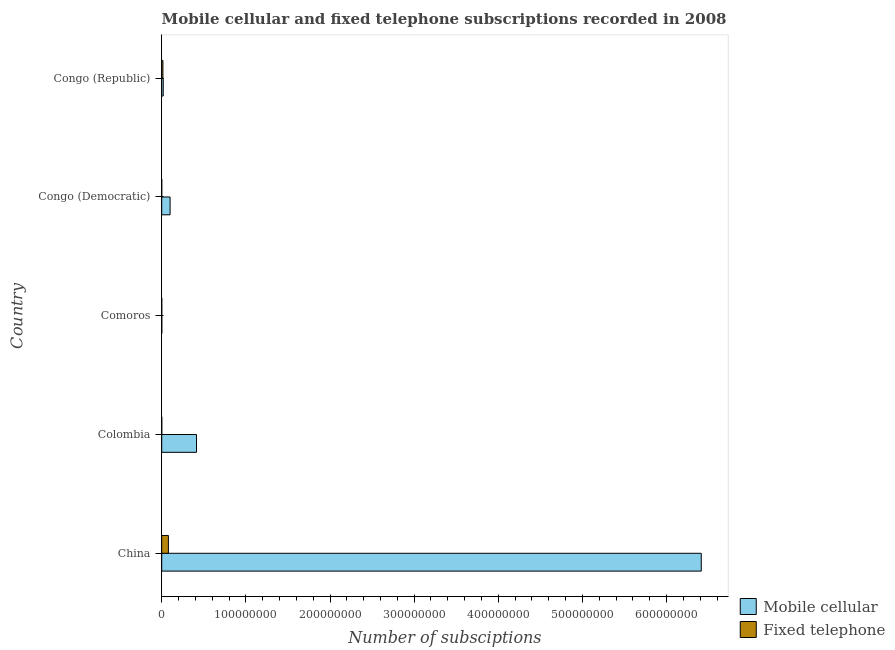How many different coloured bars are there?
Your response must be concise. 2. Are the number of bars per tick equal to the number of legend labels?
Ensure brevity in your answer.  Yes. How many bars are there on the 3rd tick from the top?
Offer a terse response. 2. What is the number of fixed telephone subscriptions in Congo (Republic)?
Keep it short and to the point. 1.44e+06. Across all countries, what is the maximum number of fixed telephone subscriptions?
Ensure brevity in your answer.  7.93e+06. Across all countries, what is the minimum number of fixed telephone subscriptions?
Ensure brevity in your answer.  9050. In which country was the number of fixed telephone subscriptions minimum?
Provide a short and direct response. Congo (Democratic). What is the total number of fixed telephone subscriptions in the graph?
Make the answer very short. 9.44e+06. What is the difference between the number of fixed telephone subscriptions in China and that in Congo (Democratic)?
Ensure brevity in your answer.  7.92e+06. What is the difference between the number of mobile cellular subscriptions in China and the number of fixed telephone subscriptions in Comoros?
Offer a terse response. 6.41e+08. What is the average number of mobile cellular subscriptions per country?
Your answer should be very brief. 1.39e+08. What is the difference between the number of fixed telephone subscriptions and number of mobile cellular subscriptions in Congo (Democratic)?
Offer a very short reply. -9.93e+06. In how many countries, is the number of fixed telephone subscriptions greater than 200000000 ?
Your answer should be compact. 0. What is the ratio of the number of mobile cellular subscriptions in China to that in Congo (Democratic)?
Provide a short and direct response. 64.53. What is the difference between the highest and the second highest number of fixed telephone subscriptions?
Your answer should be very brief. 6.49e+06. What is the difference between the highest and the lowest number of mobile cellular subscriptions?
Offer a very short reply. 6.41e+08. In how many countries, is the number of mobile cellular subscriptions greater than the average number of mobile cellular subscriptions taken over all countries?
Your answer should be compact. 1. Is the sum of the number of mobile cellular subscriptions in Colombia and Congo (Republic) greater than the maximum number of fixed telephone subscriptions across all countries?
Offer a very short reply. Yes. What does the 2nd bar from the top in Congo (Democratic) represents?
Your response must be concise. Mobile cellular. What does the 1st bar from the bottom in Comoros represents?
Make the answer very short. Mobile cellular. How many bars are there?
Your response must be concise. 10. Are all the bars in the graph horizontal?
Keep it short and to the point. Yes. What is the difference between two consecutive major ticks on the X-axis?
Provide a short and direct response. 1.00e+08. Are the values on the major ticks of X-axis written in scientific E-notation?
Keep it short and to the point. No. Where does the legend appear in the graph?
Your answer should be compact. Bottom right. How many legend labels are there?
Provide a short and direct response. 2. What is the title of the graph?
Your answer should be very brief. Mobile cellular and fixed telephone subscriptions recorded in 2008. What is the label or title of the X-axis?
Give a very brief answer. Number of subsciptions. What is the Number of subsciptions in Mobile cellular in China?
Ensure brevity in your answer.  6.41e+08. What is the Number of subsciptions of Fixed telephone in China?
Give a very brief answer. 7.93e+06. What is the Number of subsciptions of Mobile cellular in Colombia?
Your answer should be very brief. 4.14e+07. What is the Number of subsciptions in Fixed telephone in Colombia?
Provide a short and direct response. 2.88e+04. What is the Number of subsciptions of Mobile cellular in Comoros?
Ensure brevity in your answer.  9.17e+04. What is the Number of subsciptions in Fixed telephone in Comoros?
Ensure brevity in your answer.  3.73e+04. What is the Number of subsciptions in Mobile cellular in Congo (Democratic)?
Provide a short and direct response. 9.94e+06. What is the Number of subsciptions in Fixed telephone in Congo (Democratic)?
Provide a short and direct response. 9050. What is the Number of subsciptions of Mobile cellular in Congo (Republic)?
Keep it short and to the point. 1.81e+06. What is the Number of subsciptions of Fixed telephone in Congo (Republic)?
Provide a succinct answer. 1.44e+06. Across all countries, what is the maximum Number of subsciptions of Mobile cellular?
Offer a terse response. 6.41e+08. Across all countries, what is the maximum Number of subsciptions of Fixed telephone?
Provide a short and direct response. 7.93e+06. Across all countries, what is the minimum Number of subsciptions of Mobile cellular?
Provide a succinct answer. 9.17e+04. Across all countries, what is the minimum Number of subsciptions of Fixed telephone?
Your response must be concise. 9050. What is the total Number of subsciptions in Mobile cellular in the graph?
Offer a very short reply. 6.94e+08. What is the total Number of subsciptions of Fixed telephone in the graph?
Provide a short and direct response. 9.44e+06. What is the difference between the Number of subsciptions in Mobile cellular in China and that in Colombia?
Provide a short and direct response. 6.00e+08. What is the difference between the Number of subsciptions in Fixed telephone in China and that in Colombia?
Give a very brief answer. 7.90e+06. What is the difference between the Number of subsciptions of Mobile cellular in China and that in Comoros?
Make the answer very short. 6.41e+08. What is the difference between the Number of subsciptions of Fixed telephone in China and that in Comoros?
Offer a terse response. 7.89e+06. What is the difference between the Number of subsciptions in Mobile cellular in China and that in Congo (Democratic)?
Make the answer very short. 6.31e+08. What is the difference between the Number of subsciptions of Fixed telephone in China and that in Congo (Democratic)?
Offer a very short reply. 7.92e+06. What is the difference between the Number of subsciptions in Mobile cellular in China and that in Congo (Republic)?
Give a very brief answer. 6.39e+08. What is the difference between the Number of subsciptions of Fixed telephone in China and that in Congo (Republic)?
Offer a terse response. 6.49e+06. What is the difference between the Number of subsciptions in Mobile cellular in Colombia and that in Comoros?
Provide a short and direct response. 4.13e+07. What is the difference between the Number of subsciptions in Fixed telephone in Colombia and that in Comoros?
Your answer should be very brief. -8511. What is the difference between the Number of subsciptions in Mobile cellular in Colombia and that in Congo (Democratic)?
Give a very brief answer. 3.14e+07. What is the difference between the Number of subsciptions of Fixed telephone in Colombia and that in Congo (Democratic)?
Provide a succinct answer. 1.98e+04. What is the difference between the Number of subsciptions of Mobile cellular in Colombia and that in Congo (Republic)?
Offer a very short reply. 3.96e+07. What is the difference between the Number of subsciptions of Fixed telephone in Colombia and that in Congo (Republic)?
Make the answer very short. -1.41e+06. What is the difference between the Number of subsciptions of Mobile cellular in Comoros and that in Congo (Democratic)?
Provide a succinct answer. -9.85e+06. What is the difference between the Number of subsciptions of Fixed telephone in Comoros and that in Congo (Democratic)?
Give a very brief answer. 2.83e+04. What is the difference between the Number of subsciptions of Mobile cellular in Comoros and that in Congo (Republic)?
Keep it short and to the point. -1.72e+06. What is the difference between the Number of subsciptions in Fixed telephone in Comoros and that in Congo (Republic)?
Make the answer very short. -1.40e+06. What is the difference between the Number of subsciptions of Mobile cellular in Congo (Democratic) and that in Congo (Republic)?
Provide a short and direct response. 8.13e+06. What is the difference between the Number of subsciptions of Fixed telephone in Congo (Democratic) and that in Congo (Republic)?
Your answer should be compact. -1.43e+06. What is the difference between the Number of subsciptions in Mobile cellular in China and the Number of subsciptions in Fixed telephone in Colombia?
Offer a terse response. 6.41e+08. What is the difference between the Number of subsciptions of Mobile cellular in China and the Number of subsciptions of Fixed telephone in Comoros?
Provide a succinct answer. 6.41e+08. What is the difference between the Number of subsciptions of Mobile cellular in China and the Number of subsciptions of Fixed telephone in Congo (Democratic)?
Your response must be concise. 6.41e+08. What is the difference between the Number of subsciptions in Mobile cellular in China and the Number of subsciptions in Fixed telephone in Congo (Republic)?
Provide a succinct answer. 6.40e+08. What is the difference between the Number of subsciptions of Mobile cellular in Colombia and the Number of subsciptions of Fixed telephone in Comoros?
Give a very brief answer. 4.13e+07. What is the difference between the Number of subsciptions in Mobile cellular in Colombia and the Number of subsciptions in Fixed telephone in Congo (Democratic)?
Make the answer very short. 4.14e+07. What is the difference between the Number of subsciptions of Mobile cellular in Colombia and the Number of subsciptions of Fixed telephone in Congo (Republic)?
Keep it short and to the point. 3.99e+07. What is the difference between the Number of subsciptions of Mobile cellular in Comoros and the Number of subsciptions of Fixed telephone in Congo (Democratic)?
Give a very brief answer. 8.27e+04. What is the difference between the Number of subsciptions in Mobile cellular in Comoros and the Number of subsciptions in Fixed telephone in Congo (Republic)?
Your answer should be very brief. -1.35e+06. What is the difference between the Number of subsciptions in Mobile cellular in Congo (Democratic) and the Number of subsciptions in Fixed telephone in Congo (Republic)?
Provide a succinct answer. 8.50e+06. What is the average Number of subsciptions in Mobile cellular per country?
Your answer should be very brief. 1.39e+08. What is the average Number of subsciptions of Fixed telephone per country?
Ensure brevity in your answer.  1.89e+06. What is the difference between the Number of subsciptions in Mobile cellular and Number of subsciptions in Fixed telephone in China?
Keep it short and to the point. 6.33e+08. What is the difference between the Number of subsciptions in Mobile cellular and Number of subsciptions in Fixed telephone in Colombia?
Offer a terse response. 4.13e+07. What is the difference between the Number of subsciptions in Mobile cellular and Number of subsciptions in Fixed telephone in Comoros?
Offer a terse response. 5.44e+04. What is the difference between the Number of subsciptions in Mobile cellular and Number of subsciptions in Fixed telephone in Congo (Democratic)?
Your response must be concise. 9.93e+06. What is the difference between the Number of subsciptions of Mobile cellular and Number of subsciptions of Fixed telephone in Congo (Republic)?
Your response must be concise. 3.69e+05. What is the ratio of the Number of subsciptions of Mobile cellular in China to that in Colombia?
Keep it short and to the point. 15.5. What is the ratio of the Number of subsciptions in Fixed telephone in China to that in Colombia?
Keep it short and to the point. 275.22. What is the ratio of the Number of subsciptions of Mobile cellular in China to that in Comoros?
Make the answer very short. 6989.73. What is the ratio of the Number of subsciptions of Fixed telephone in China to that in Comoros?
Ensure brevity in your answer.  212.46. What is the ratio of the Number of subsciptions of Mobile cellular in China to that in Congo (Democratic)?
Your response must be concise. 64.53. What is the ratio of the Number of subsciptions of Fixed telephone in China to that in Congo (Democratic)?
Provide a short and direct response. 876.13. What is the ratio of the Number of subsciptions in Mobile cellular in China to that in Congo (Republic)?
Your answer should be very brief. 354.87. What is the ratio of the Number of subsciptions of Fixed telephone in China to that in Congo (Republic)?
Your response must be concise. 5.51. What is the ratio of the Number of subsciptions of Mobile cellular in Colombia to that in Comoros?
Offer a very short reply. 450.89. What is the ratio of the Number of subsciptions in Fixed telephone in Colombia to that in Comoros?
Offer a terse response. 0.77. What is the ratio of the Number of subsciptions of Mobile cellular in Colombia to that in Congo (Democratic)?
Your response must be concise. 4.16. What is the ratio of the Number of subsciptions in Fixed telephone in Colombia to that in Congo (Democratic)?
Ensure brevity in your answer.  3.18. What is the ratio of the Number of subsciptions in Mobile cellular in Colombia to that in Congo (Republic)?
Make the answer very short. 22.89. What is the ratio of the Number of subsciptions of Mobile cellular in Comoros to that in Congo (Democratic)?
Provide a short and direct response. 0.01. What is the ratio of the Number of subsciptions in Fixed telephone in Comoros to that in Congo (Democratic)?
Your answer should be very brief. 4.12. What is the ratio of the Number of subsciptions of Mobile cellular in Comoros to that in Congo (Republic)?
Your response must be concise. 0.05. What is the ratio of the Number of subsciptions of Fixed telephone in Comoros to that in Congo (Republic)?
Provide a short and direct response. 0.03. What is the ratio of the Number of subsciptions in Mobile cellular in Congo (Democratic) to that in Congo (Republic)?
Offer a very short reply. 5.5. What is the ratio of the Number of subsciptions in Fixed telephone in Congo (Democratic) to that in Congo (Republic)?
Your answer should be compact. 0.01. What is the difference between the highest and the second highest Number of subsciptions of Mobile cellular?
Ensure brevity in your answer.  6.00e+08. What is the difference between the highest and the second highest Number of subsciptions in Fixed telephone?
Make the answer very short. 6.49e+06. What is the difference between the highest and the lowest Number of subsciptions in Mobile cellular?
Make the answer very short. 6.41e+08. What is the difference between the highest and the lowest Number of subsciptions of Fixed telephone?
Offer a terse response. 7.92e+06. 